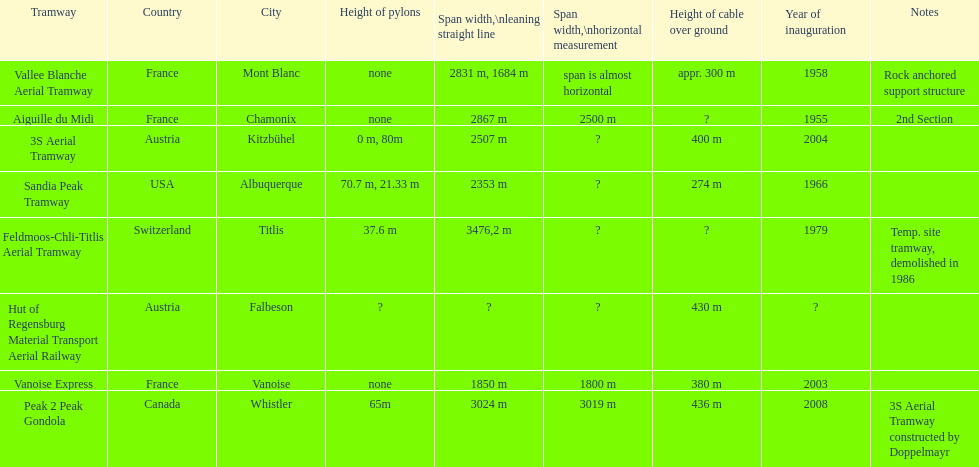At least how many aerial tramways were inaugurated after 1970? 4. 